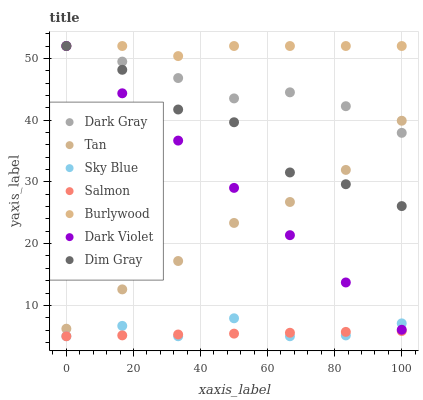Does Salmon have the minimum area under the curve?
Answer yes or no. Yes. Does Burlywood have the maximum area under the curve?
Answer yes or no. Yes. Does Burlywood have the minimum area under the curve?
Answer yes or no. No. Does Salmon have the maximum area under the curve?
Answer yes or no. No. Is Salmon the smoothest?
Answer yes or no. Yes. Is Dim Gray the roughest?
Answer yes or no. Yes. Is Burlywood the smoothest?
Answer yes or no. No. Is Burlywood the roughest?
Answer yes or no. No. Does Salmon have the lowest value?
Answer yes or no. Yes. Does Burlywood have the lowest value?
Answer yes or no. No. Does Dark Gray have the highest value?
Answer yes or no. Yes. Does Salmon have the highest value?
Answer yes or no. No. Is Sky Blue less than Dim Gray?
Answer yes or no. Yes. Is Burlywood greater than Sky Blue?
Answer yes or no. Yes. Does Dark Gray intersect Burlywood?
Answer yes or no. Yes. Is Dark Gray less than Burlywood?
Answer yes or no. No. Is Dark Gray greater than Burlywood?
Answer yes or no. No. Does Sky Blue intersect Dim Gray?
Answer yes or no. No. 